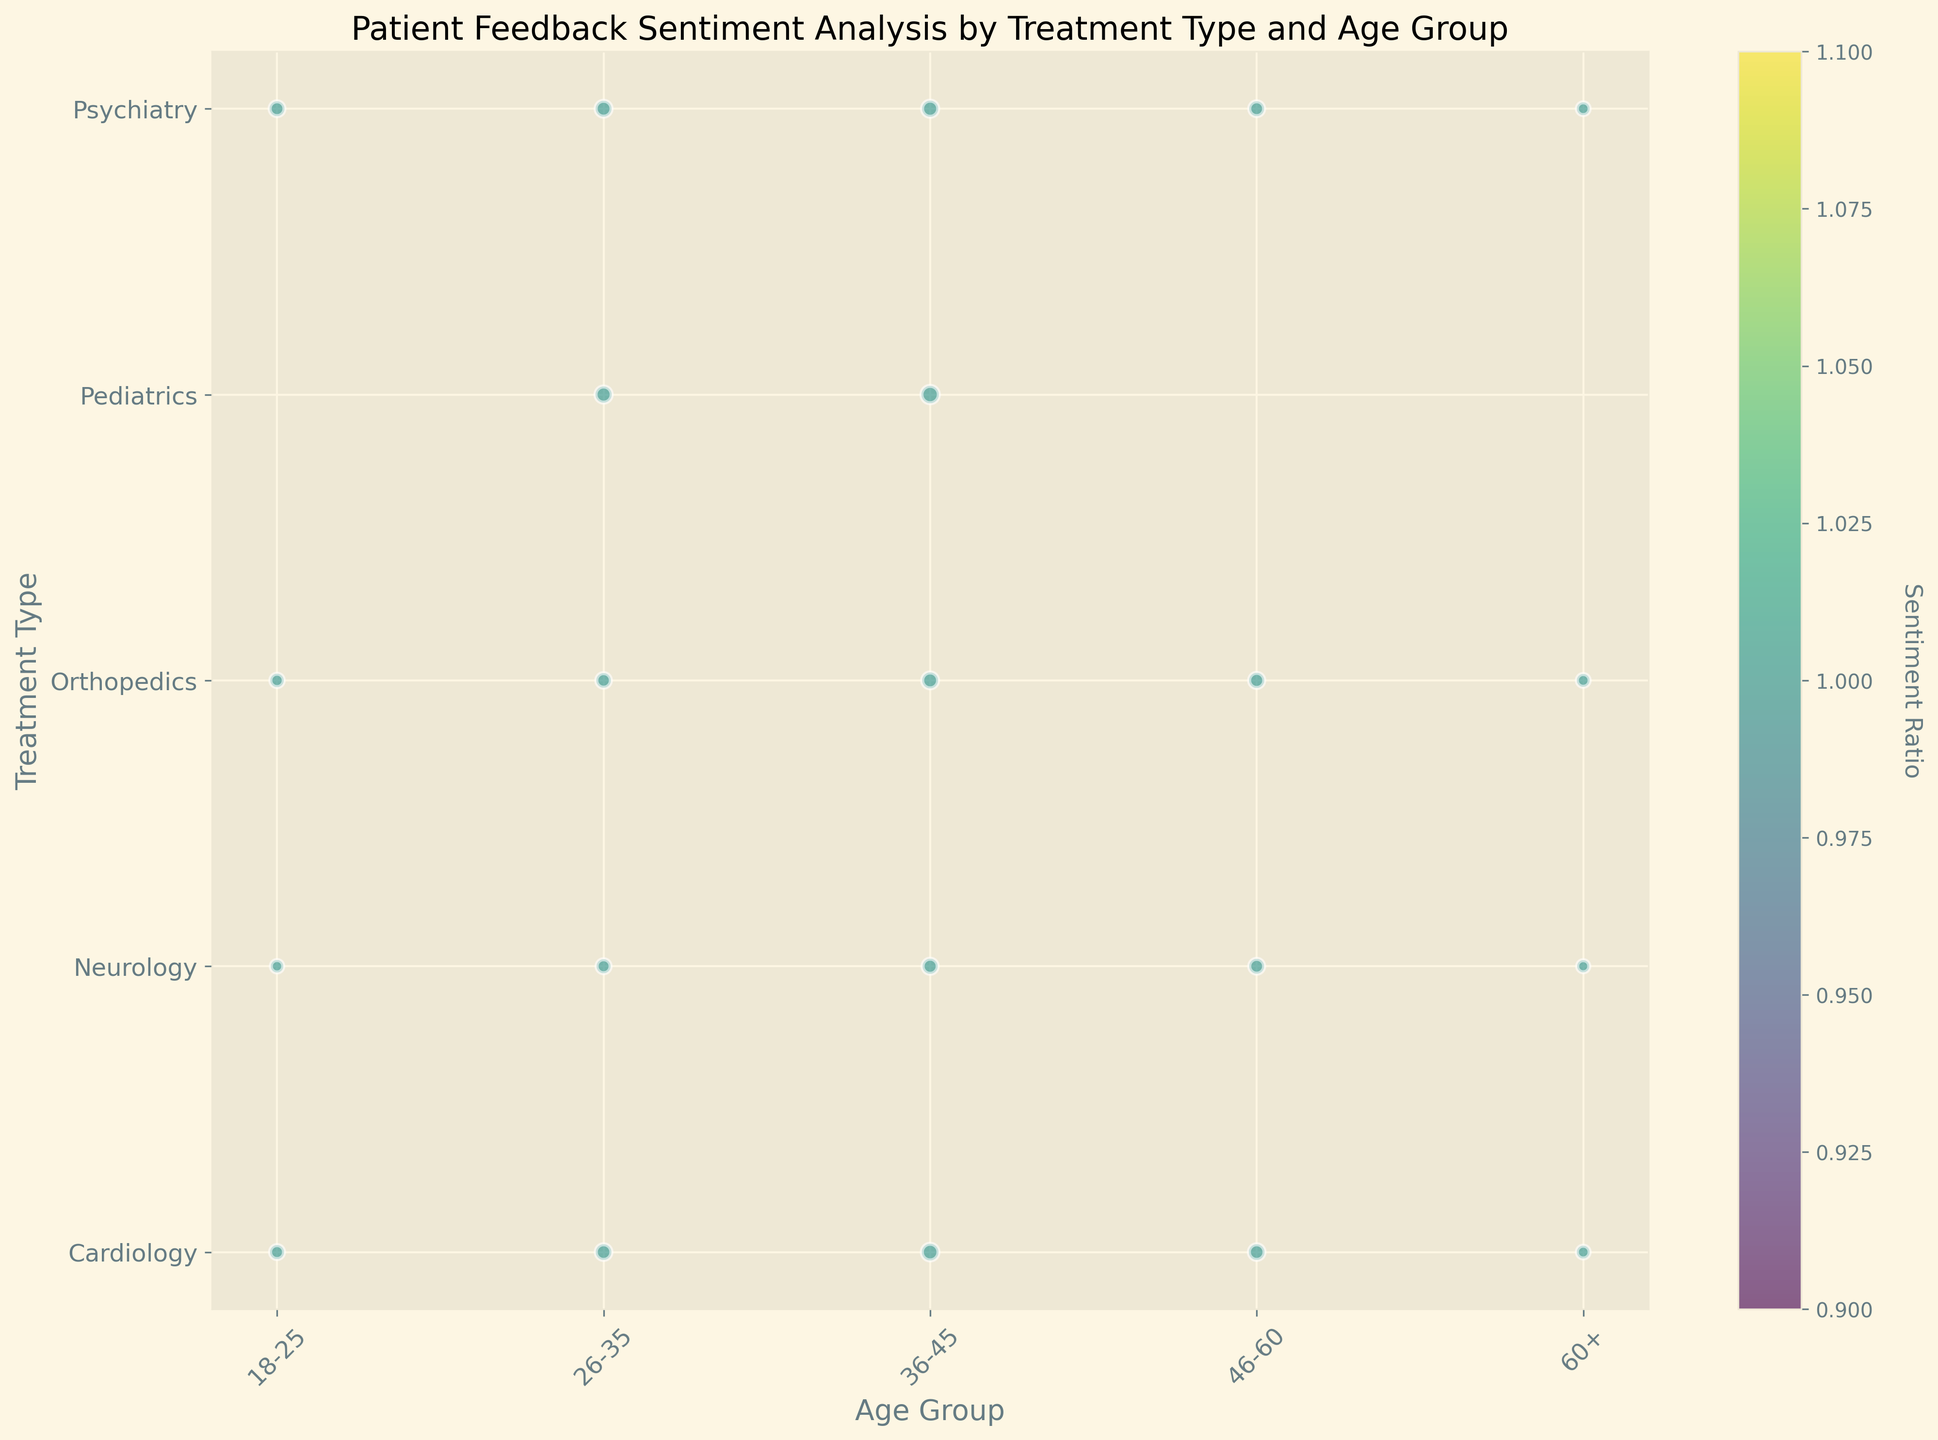What age group in Cardiology has the highest number of feedback? To find the answer, look at the bubble that has the largest size in the row corresponding to "Cardiology." The largest bubble in the Cardiology row belongs to the 36-45 age group.
Answer: 36-45 Which age group in Orthopedics has the highest sentiment ratio? Look at the color of the bubbles in the Orthopedics row. The bubble with the most intense color represents the highest sentiment ratio, which is in the 36-45 age group.
Answer: 36-45 Between Neurology and Psychiatry for the age group 26-35, which treatment type has a larger positive sentiment? Compare the position of the bubbles for the 26-35 age group in the rows for Neurology and Psychiatry to the positive sentiment on the y-axis. Psychiatry has a larger bubble size.
Answer: Psychiatry What is the sentiment ratio for the 60+ age group in Cardiology? Find the 60+ age group under the Cardiology row and observe the color intensity of the bubble, then refer to the color bar to gauge the sentiment ratio. The lighter color corresponds to a sentiment ratio roughly around 1.
Answer: ~1 Compare the number of feedbacks of Pediatrics for the 26-35 age group with the 18-25 age group. The bubble for the 26-35 age group in Pediatrics is large, whereas there is no bubble for the 18-25 age group in Pediatrics, indicating that the number of feedback is 0 for 18-25 age group while it is substantial for 26-35.
Answer: 26-35 > 18-25 Which treatment type has no feedback for multiple age groups, and what are those age groups? Look for rows with bubbles missing in multiple age groups. Pediatrics has no bubbles for the 18-25, 46-60, and 60+ age groups.
Answer: Pediatrics: 18-25, 46-60, 60+ What is the trend of positive sentiment for Cardiology across different age groups? Observe the color and size of bubbles across the age groups in the Cardiology row. The positive sentiment starts at a low level in the 18-25 age group, peaks at 36-45, and declines for older age groups.
Answer: Peaks at 36-45, then declines What's the relative size of feedback bubbles between Orthopedics and Neurology for the 36-45 age group? Compare the sizes of the bubbles for the 36-45 age group in both Orthopedics and Neurology rows. Orthopedics has a larger bubble size than Neurology.
Answer: Orthopedics > Neurology Which age group in Psychiatry has the smallest sentiment ratio? Look at the color of bubbles in the Psychiatry row. The bubble with the least intense color, indicating the smallest sentiment ratio, is the 60+ age group.
Answer: 60+ For the 46-60 age group, which treatment types have an expressed sentiment ratio of approximately 90% or more? Look at the color of bubbles in the 46-60 age group column. Neurology and Psychiatry have darker bubbles, indicating a higher sentiment ratio of around 90% or more.
Answer: Neurology, Psychiatry 